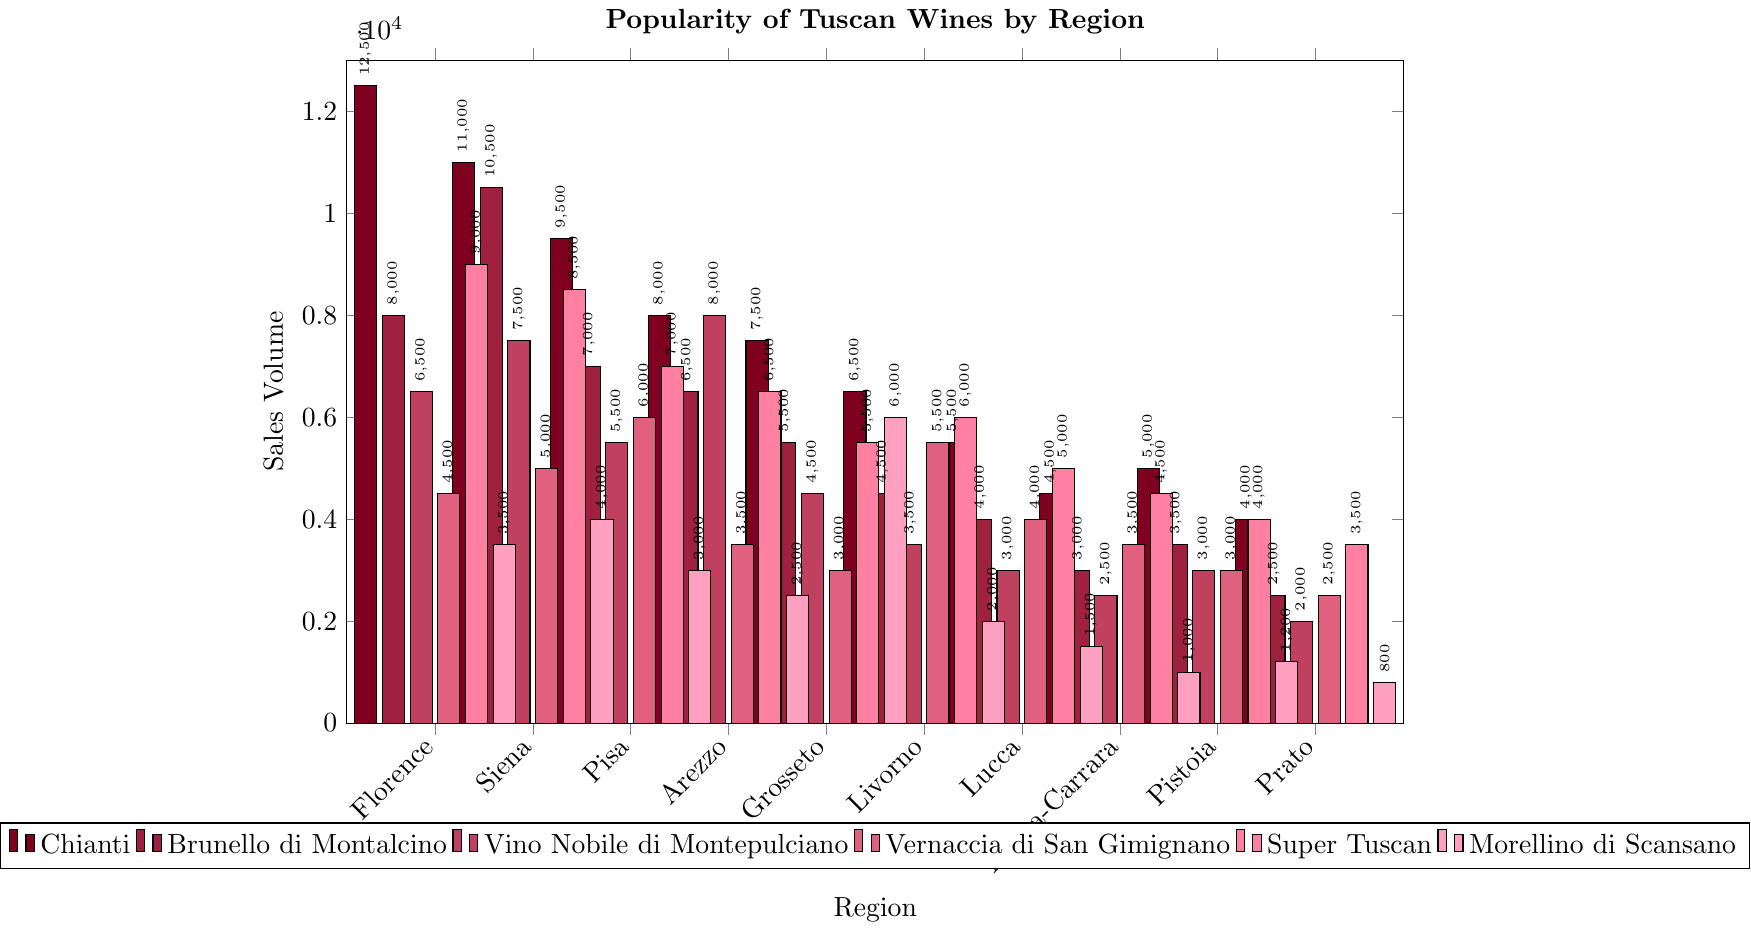What is the most popular wine in the Florence region? Look for the highest bar among the wines for the Florence region. Chianti has the highest sales volume of 12,500 among the wines listed.
Answer: Chianti Which region has the highest sales volume of Brunello di Montalcino? Compare the heights of the bars representing Brunello di Montalcino for each region. Siena has the highest bar with a sales volume of 10,500.
Answer: Siena What is the total sales volume of Vernaccia di San Gimignano across all regions? Sum up the sales volumes of Vernaccia di San Gimignano for all regions: 4500 + 5000 + 6000 + 3500 + 3000 + 5500 + 4000 + 3500 + 3000 + 2500 = 40,000.
Answer: 40,000 Which region sells more Chianti than Super Tuscan? Compare the sales volumes of Chianti and Super Tuscan for each region. Florence, Pisa, and Prato have higher sales volumes of Chianti than Super Tuscan.
Answer: Florence, Pisa, Prato In which region is Vino Nobile di Montepulciano the most popular compared to the other regions? Identify the region with the highest bar representing Vino Nobile di Montepulciano. Arezzo has the highest sales volume of 8,000 for Vino Nobile di Montepulciano.
Answer: Arezzo What is the average sales volume of Morellino di Scansano across all regions? Sum up the sales volumes of Morellino di Scansano for all regions and divide by the number of regions: (3500 + 4000 + 3000 + 2500 + 6000 + 2000 + 1500 + 1000 + 1200 + 800) / 10 = 25,500 / 10 = 2,550.
Answer: 2,550 What is the combined sales volume of Chianti and Brunello di Montalcino in Siena? Add the sales volumes of Chianti and Brunello di Montalcino in Siena: 11,000 + 10,500 = 21,500.
Answer: 21,500 Which wine has the least sales volume in Livorno? Look for the smallest bar in Livorno. Morellino di Scansano has the smallest sales volume of 2,000.
Answer: Morellino di Scansano 